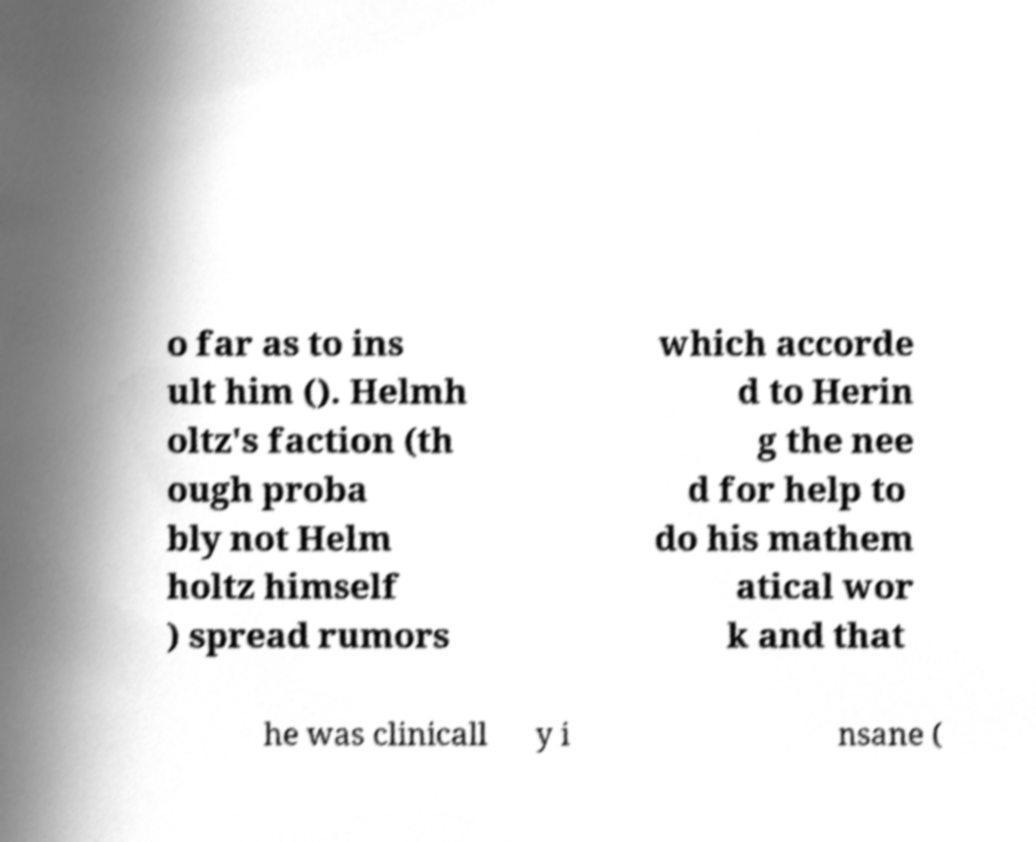For documentation purposes, I need the text within this image transcribed. Could you provide that? o far as to ins ult him (). Helmh oltz's faction (th ough proba bly not Helm holtz himself ) spread rumors which accorde d to Herin g the nee d for help to do his mathem atical wor k and that he was clinicall y i nsane ( 